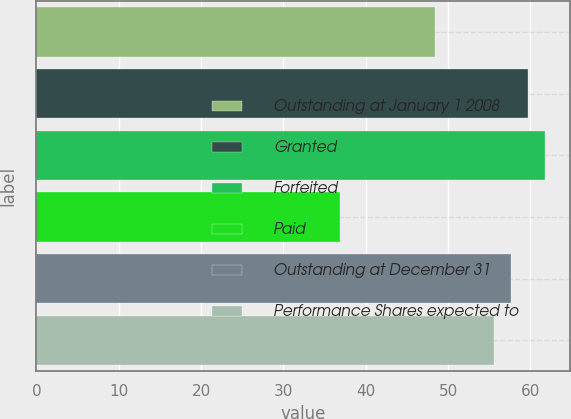<chart> <loc_0><loc_0><loc_500><loc_500><bar_chart><fcel>Outstanding at January 1 2008<fcel>Granted<fcel>Forfeited<fcel>Paid<fcel>Outstanding at December 31<fcel>Performance Shares expected to<nl><fcel>48.39<fcel>59.68<fcel>61.74<fcel>36.87<fcel>57.62<fcel>55.56<nl></chart> 